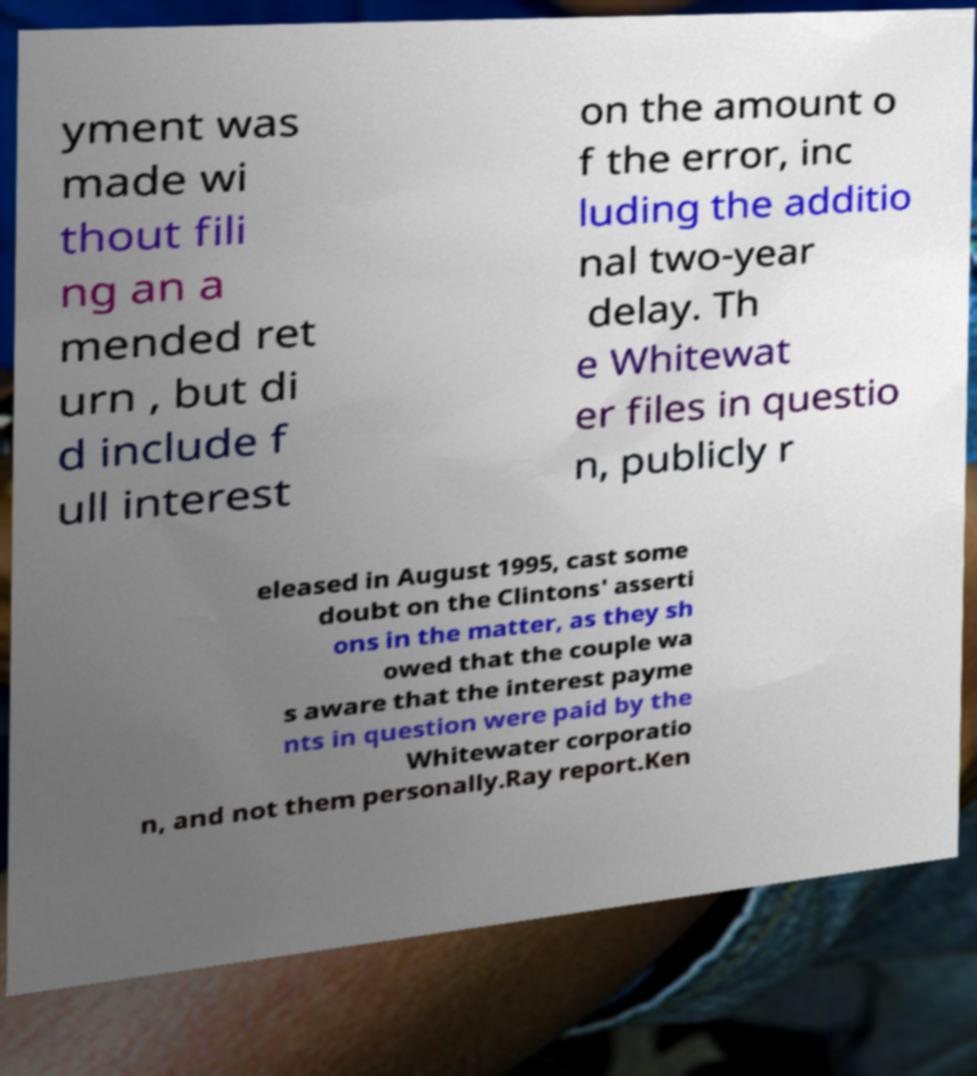Could you assist in decoding the text presented in this image and type it out clearly? yment was made wi thout fili ng an a mended ret urn , but di d include f ull interest on the amount o f the error, inc luding the additio nal two-year delay. Th e Whitewat er files in questio n, publicly r eleased in August 1995, cast some doubt on the Clintons' asserti ons in the matter, as they sh owed that the couple wa s aware that the interest payme nts in question were paid by the Whitewater corporatio n, and not them personally.Ray report.Ken 